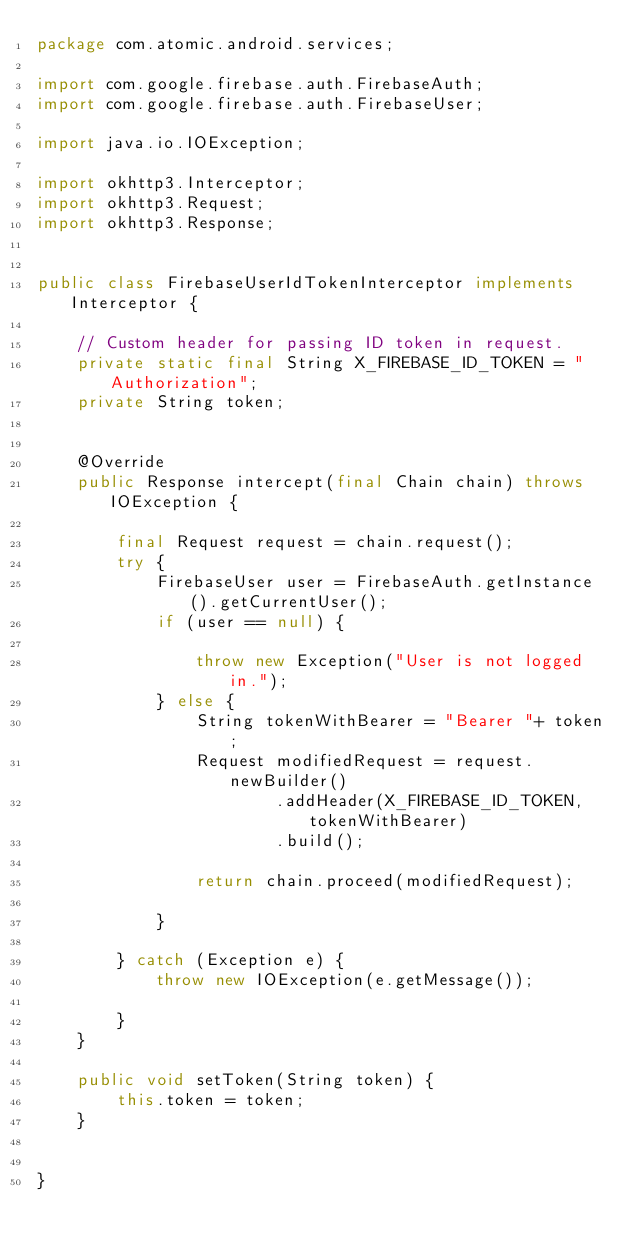Convert code to text. <code><loc_0><loc_0><loc_500><loc_500><_Java_>package com.atomic.android.services;

import com.google.firebase.auth.FirebaseAuth;
import com.google.firebase.auth.FirebaseUser;

import java.io.IOException;

import okhttp3.Interceptor;
import okhttp3.Request;
import okhttp3.Response;


public class FirebaseUserIdTokenInterceptor implements Interceptor {

    // Custom header for passing ID token in request.
    private static final String X_FIREBASE_ID_TOKEN = "Authorization";
    private String token;


    @Override
    public Response intercept(final Chain chain) throws IOException {

        final Request request = chain.request();
        try {
            FirebaseUser user = FirebaseAuth.getInstance().getCurrentUser();
            if (user == null) {

                throw new Exception("User is not logged in.");
            } else {
                String tokenWithBearer = "Bearer "+ token;
                Request modifiedRequest = request.newBuilder()
                        .addHeader(X_FIREBASE_ID_TOKEN, tokenWithBearer)
                        .build();

                return chain.proceed(modifiedRequest);

            }

        } catch (Exception e) {
            throw new IOException(e.getMessage());

        }
    }

    public void setToken(String token) {
        this.token = token;
    }


}</code> 